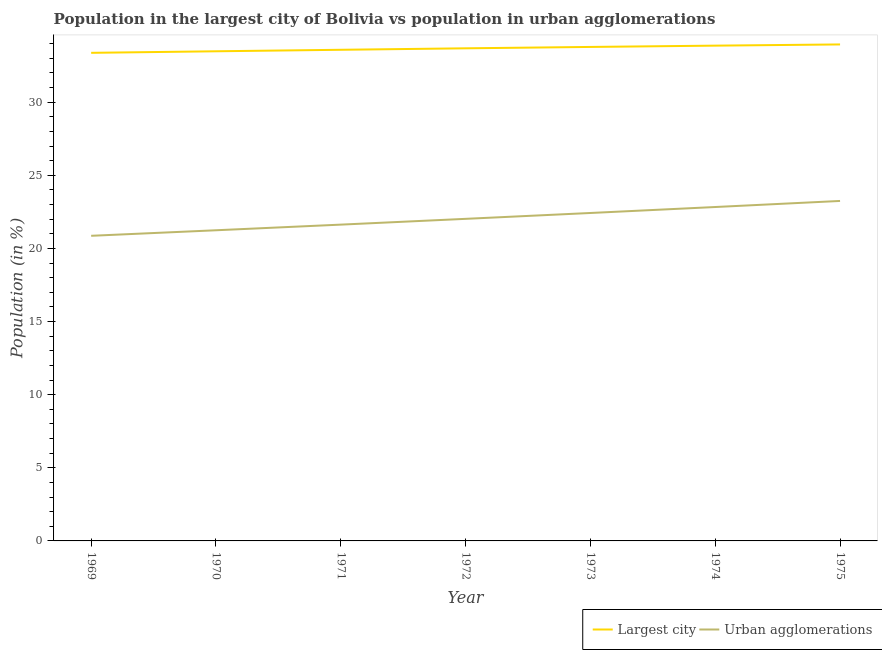Does the line corresponding to population in the largest city intersect with the line corresponding to population in urban agglomerations?
Keep it short and to the point. No. What is the population in the largest city in 1970?
Make the answer very short. 33.48. Across all years, what is the maximum population in urban agglomerations?
Give a very brief answer. 23.25. Across all years, what is the minimum population in urban agglomerations?
Your response must be concise. 20.86. In which year was the population in the largest city maximum?
Your response must be concise. 1975. In which year was the population in urban agglomerations minimum?
Offer a very short reply. 1969. What is the total population in the largest city in the graph?
Offer a terse response. 235.7. What is the difference between the population in urban agglomerations in 1969 and that in 1970?
Ensure brevity in your answer.  -0.38. What is the difference between the population in urban agglomerations in 1969 and the population in the largest city in 1973?
Provide a short and direct response. -12.91. What is the average population in the largest city per year?
Keep it short and to the point. 33.67. In the year 1971, what is the difference between the population in the largest city and population in urban agglomerations?
Your response must be concise. 11.95. In how many years, is the population in the largest city greater than 31 %?
Offer a terse response. 7. What is the ratio of the population in urban agglomerations in 1970 to that in 1975?
Provide a short and direct response. 0.91. What is the difference between the highest and the second highest population in urban agglomerations?
Ensure brevity in your answer.  0.42. What is the difference between the highest and the lowest population in urban agglomerations?
Offer a terse response. 2.38. Is the sum of the population in the largest city in 1969 and 1974 greater than the maximum population in urban agglomerations across all years?
Offer a very short reply. Yes. Is the population in the largest city strictly less than the population in urban agglomerations over the years?
Your answer should be very brief. No. How many years are there in the graph?
Your response must be concise. 7. Are the values on the major ticks of Y-axis written in scientific E-notation?
Offer a terse response. No. How many legend labels are there?
Make the answer very short. 2. What is the title of the graph?
Your answer should be very brief. Population in the largest city of Bolivia vs population in urban agglomerations. Does "Primary completion rate" appear as one of the legend labels in the graph?
Your answer should be compact. No. What is the label or title of the Y-axis?
Offer a terse response. Population (in %). What is the Population (in %) of Largest city in 1969?
Ensure brevity in your answer.  33.37. What is the Population (in %) in Urban agglomerations in 1969?
Ensure brevity in your answer.  20.86. What is the Population (in %) in Largest city in 1970?
Offer a terse response. 33.48. What is the Population (in %) of Urban agglomerations in 1970?
Ensure brevity in your answer.  21.24. What is the Population (in %) of Largest city in 1971?
Give a very brief answer. 33.58. What is the Population (in %) of Urban agglomerations in 1971?
Offer a terse response. 21.63. What is the Population (in %) of Largest city in 1972?
Offer a very short reply. 33.68. What is the Population (in %) in Urban agglomerations in 1972?
Give a very brief answer. 22.02. What is the Population (in %) in Largest city in 1973?
Provide a succinct answer. 33.78. What is the Population (in %) of Urban agglomerations in 1973?
Make the answer very short. 22.42. What is the Population (in %) in Largest city in 1974?
Make the answer very short. 33.87. What is the Population (in %) in Urban agglomerations in 1974?
Your response must be concise. 22.83. What is the Population (in %) in Largest city in 1975?
Offer a terse response. 33.95. What is the Population (in %) in Urban agglomerations in 1975?
Offer a very short reply. 23.25. Across all years, what is the maximum Population (in %) of Largest city?
Your response must be concise. 33.95. Across all years, what is the maximum Population (in %) in Urban agglomerations?
Ensure brevity in your answer.  23.25. Across all years, what is the minimum Population (in %) in Largest city?
Provide a succinct answer. 33.37. Across all years, what is the minimum Population (in %) of Urban agglomerations?
Provide a short and direct response. 20.86. What is the total Population (in %) of Largest city in the graph?
Your answer should be compact. 235.7. What is the total Population (in %) of Urban agglomerations in the graph?
Provide a succinct answer. 154.25. What is the difference between the Population (in %) of Largest city in 1969 and that in 1970?
Your answer should be compact. -0.11. What is the difference between the Population (in %) in Urban agglomerations in 1969 and that in 1970?
Offer a terse response. -0.38. What is the difference between the Population (in %) of Largest city in 1969 and that in 1971?
Your answer should be compact. -0.21. What is the difference between the Population (in %) of Urban agglomerations in 1969 and that in 1971?
Your response must be concise. -0.76. What is the difference between the Population (in %) of Largest city in 1969 and that in 1972?
Offer a terse response. -0.31. What is the difference between the Population (in %) in Urban agglomerations in 1969 and that in 1972?
Offer a terse response. -1.16. What is the difference between the Population (in %) in Largest city in 1969 and that in 1973?
Keep it short and to the point. -0.4. What is the difference between the Population (in %) of Urban agglomerations in 1969 and that in 1973?
Your answer should be compact. -1.56. What is the difference between the Population (in %) of Largest city in 1969 and that in 1974?
Offer a terse response. -0.49. What is the difference between the Population (in %) of Urban agglomerations in 1969 and that in 1974?
Your response must be concise. -1.97. What is the difference between the Population (in %) of Largest city in 1969 and that in 1975?
Ensure brevity in your answer.  -0.57. What is the difference between the Population (in %) in Urban agglomerations in 1969 and that in 1975?
Offer a very short reply. -2.38. What is the difference between the Population (in %) of Largest city in 1970 and that in 1971?
Offer a terse response. -0.1. What is the difference between the Population (in %) in Urban agglomerations in 1970 and that in 1971?
Your response must be concise. -0.39. What is the difference between the Population (in %) of Largest city in 1970 and that in 1972?
Make the answer very short. -0.2. What is the difference between the Population (in %) of Urban agglomerations in 1970 and that in 1972?
Give a very brief answer. -0.78. What is the difference between the Population (in %) in Largest city in 1970 and that in 1973?
Your answer should be very brief. -0.3. What is the difference between the Population (in %) in Urban agglomerations in 1970 and that in 1973?
Your answer should be very brief. -1.18. What is the difference between the Population (in %) of Largest city in 1970 and that in 1974?
Provide a succinct answer. -0.39. What is the difference between the Population (in %) in Urban agglomerations in 1970 and that in 1974?
Keep it short and to the point. -1.59. What is the difference between the Population (in %) in Largest city in 1970 and that in 1975?
Give a very brief answer. -0.47. What is the difference between the Population (in %) in Urban agglomerations in 1970 and that in 1975?
Keep it short and to the point. -2. What is the difference between the Population (in %) of Largest city in 1971 and that in 1972?
Offer a very short reply. -0.1. What is the difference between the Population (in %) in Urban agglomerations in 1971 and that in 1972?
Ensure brevity in your answer.  -0.4. What is the difference between the Population (in %) in Largest city in 1971 and that in 1973?
Offer a terse response. -0.19. What is the difference between the Population (in %) of Urban agglomerations in 1971 and that in 1973?
Provide a short and direct response. -0.8. What is the difference between the Population (in %) of Largest city in 1971 and that in 1974?
Ensure brevity in your answer.  -0.28. What is the difference between the Population (in %) in Urban agglomerations in 1971 and that in 1974?
Your answer should be compact. -1.2. What is the difference between the Population (in %) in Largest city in 1971 and that in 1975?
Your response must be concise. -0.37. What is the difference between the Population (in %) in Urban agglomerations in 1971 and that in 1975?
Ensure brevity in your answer.  -1.62. What is the difference between the Population (in %) of Largest city in 1972 and that in 1973?
Ensure brevity in your answer.  -0.09. What is the difference between the Population (in %) of Urban agglomerations in 1972 and that in 1973?
Ensure brevity in your answer.  -0.4. What is the difference between the Population (in %) in Largest city in 1972 and that in 1974?
Provide a succinct answer. -0.18. What is the difference between the Population (in %) of Urban agglomerations in 1972 and that in 1974?
Offer a very short reply. -0.81. What is the difference between the Population (in %) of Largest city in 1972 and that in 1975?
Ensure brevity in your answer.  -0.26. What is the difference between the Population (in %) of Urban agglomerations in 1972 and that in 1975?
Ensure brevity in your answer.  -1.22. What is the difference between the Population (in %) of Largest city in 1973 and that in 1974?
Ensure brevity in your answer.  -0.09. What is the difference between the Population (in %) of Urban agglomerations in 1973 and that in 1974?
Your response must be concise. -0.41. What is the difference between the Population (in %) of Largest city in 1973 and that in 1975?
Your answer should be very brief. -0.17. What is the difference between the Population (in %) of Urban agglomerations in 1973 and that in 1975?
Offer a terse response. -0.82. What is the difference between the Population (in %) in Largest city in 1974 and that in 1975?
Offer a terse response. -0.08. What is the difference between the Population (in %) of Urban agglomerations in 1974 and that in 1975?
Offer a very short reply. -0.42. What is the difference between the Population (in %) in Largest city in 1969 and the Population (in %) in Urban agglomerations in 1970?
Your answer should be very brief. 12.13. What is the difference between the Population (in %) in Largest city in 1969 and the Population (in %) in Urban agglomerations in 1971?
Your response must be concise. 11.75. What is the difference between the Population (in %) of Largest city in 1969 and the Population (in %) of Urban agglomerations in 1972?
Keep it short and to the point. 11.35. What is the difference between the Population (in %) of Largest city in 1969 and the Population (in %) of Urban agglomerations in 1973?
Provide a short and direct response. 10.95. What is the difference between the Population (in %) in Largest city in 1969 and the Population (in %) in Urban agglomerations in 1974?
Offer a terse response. 10.54. What is the difference between the Population (in %) of Largest city in 1969 and the Population (in %) of Urban agglomerations in 1975?
Provide a succinct answer. 10.13. What is the difference between the Population (in %) of Largest city in 1970 and the Population (in %) of Urban agglomerations in 1971?
Offer a very short reply. 11.85. What is the difference between the Population (in %) in Largest city in 1970 and the Population (in %) in Urban agglomerations in 1972?
Make the answer very short. 11.46. What is the difference between the Population (in %) in Largest city in 1970 and the Population (in %) in Urban agglomerations in 1973?
Provide a succinct answer. 11.06. What is the difference between the Population (in %) of Largest city in 1970 and the Population (in %) of Urban agglomerations in 1974?
Ensure brevity in your answer.  10.65. What is the difference between the Population (in %) of Largest city in 1970 and the Population (in %) of Urban agglomerations in 1975?
Ensure brevity in your answer.  10.23. What is the difference between the Population (in %) in Largest city in 1971 and the Population (in %) in Urban agglomerations in 1972?
Provide a short and direct response. 11.56. What is the difference between the Population (in %) in Largest city in 1971 and the Population (in %) in Urban agglomerations in 1973?
Give a very brief answer. 11.16. What is the difference between the Population (in %) of Largest city in 1971 and the Population (in %) of Urban agglomerations in 1974?
Provide a succinct answer. 10.75. What is the difference between the Population (in %) in Largest city in 1971 and the Population (in %) in Urban agglomerations in 1975?
Ensure brevity in your answer.  10.34. What is the difference between the Population (in %) of Largest city in 1972 and the Population (in %) of Urban agglomerations in 1973?
Offer a terse response. 11.26. What is the difference between the Population (in %) in Largest city in 1972 and the Population (in %) in Urban agglomerations in 1974?
Offer a terse response. 10.85. What is the difference between the Population (in %) of Largest city in 1972 and the Population (in %) of Urban agglomerations in 1975?
Provide a succinct answer. 10.44. What is the difference between the Population (in %) in Largest city in 1973 and the Population (in %) in Urban agglomerations in 1974?
Your answer should be very brief. 10.95. What is the difference between the Population (in %) of Largest city in 1973 and the Population (in %) of Urban agglomerations in 1975?
Provide a succinct answer. 10.53. What is the difference between the Population (in %) of Largest city in 1974 and the Population (in %) of Urban agglomerations in 1975?
Ensure brevity in your answer.  10.62. What is the average Population (in %) in Largest city per year?
Your answer should be compact. 33.67. What is the average Population (in %) of Urban agglomerations per year?
Offer a terse response. 22.04. In the year 1969, what is the difference between the Population (in %) of Largest city and Population (in %) of Urban agglomerations?
Your answer should be compact. 12.51. In the year 1970, what is the difference between the Population (in %) in Largest city and Population (in %) in Urban agglomerations?
Provide a short and direct response. 12.24. In the year 1971, what is the difference between the Population (in %) in Largest city and Population (in %) in Urban agglomerations?
Make the answer very short. 11.95. In the year 1972, what is the difference between the Population (in %) in Largest city and Population (in %) in Urban agglomerations?
Your answer should be compact. 11.66. In the year 1973, what is the difference between the Population (in %) of Largest city and Population (in %) of Urban agglomerations?
Provide a short and direct response. 11.35. In the year 1974, what is the difference between the Population (in %) of Largest city and Population (in %) of Urban agglomerations?
Give a very brief answer. 11.03. In the year 1975, what is the difference between the Population (in %) of Largest city and Population (in %) of Urban agglomerations?
Provide a short and direct response. 10.7. What is the ratio of the Population (in %) in Urban agglomerations in 1969 to that in 1970?
Offer a very short reply. 0.98. What is the ratio of the Population (in %) of Urban agglomerations in 1969 to that in 1971?
Your answer should be very brief. 0.96. What is the ratio of the Population (in %) of Largest city in 1969 to that in 1972?
Provide a short and direct response. 0.99. What is the ratio of the Population (in %) in Urban agglomerations in 1969 to that in 1972?
Keep it short and to the point. 0.95. What is the ratio of the Population (in %) in Urban agglomerations in 1969 to that in 1973?
Your response must be concise. 0.93. What is the ratio of the Population (in %) in Largest city in 1969 to that in 1974?
Your response must be concise. 0.99. What is the ratio of the Population (in %) of Urban agglomerations in 1969 to that in 1974?
Keep it short and to the point. 0.91. What is the ratio of the Population (in %) of Largest city in 1969 to that in 1975?
Offer a very short reply. 0.98. What is the ratio of the Population (in %) in Urban agglomerations in 1969 to that in 1975?
Make the answer very short. 0.9. What is the ratio of the Population (in %) of Largest city in 1970 to that in 1971?
Keep it short and to the point. 1. What is the ratio of the Population (in %) in Urban agglomerations in 1970 to that in 1971?
Ensure brevity in your answer.  0.98. What is the ratio of the Population (in %) in Largest city in 1970 to that in 1972?
Provide a succinct answer. 0.99. What is the ratio of the Population (in %) in Urban agglomerations in 1970 to that in 1972?
Give a very brief answer. 0.96. What is the ratio of the Population (in %) in Urban agglomerations in 1970 to that in 1973?
Your answer should be very brief. 0.95. What is the ratio of the Population (in %) of Urban agglomerations in 1970 to that in 1974?
Your response must be concise. 0.93. What is the ratio of the Population (in %) of Largest city in 1970 to that in 1975?
Provide a succinct answer. 0.99. What is the ratio of the Population (in %) of Urban agglomerations in 1970 to that in 1975?
Provide a short and direct response. 0.91. What is the ratio of the Population (in %) in Urban agglomerations in 1971 to that in 1972?
Your answer should be very brief. 0.98. What is the ratio of the Population (in %) of Largest city in 1971 to that in 1973?
Make the answer very short. 0.99. What is the ratio of the Population (in %) of Urban agglomerations in 1971 to that in 1973?
Provide a short and direct response. 0.96. What is the ratio of the Population (in %) of Urban agglomerations in 1971 to that in 1974?
Provide a short and direct response. 0.95. What is the ratio of the Population (in %) in Urban agglomerations in 1971 to that in 1975?
Provide a succinct answer. 0.93. What is the ratio of the Population (in %) of Urban agglomerations in 1972 to that in 1973?
Make the answer very short. 0.98. What is the ratio of the Population (in %) of Largest city in 1972 to that in 1974?
Keep it short and to the point. 0.99. What is the ratio of the Population (in %) of Urban agglomerations in 1972 to that in 1974?
Offer a very short reply. 0.96. What is the ratio of the Population (in %) in Largest city in 1972 to that in 1975?
Your answer should be compact. 0.99. What is the ratio of the Population (in %) in Urban agglomerations in 1972 to that in 1975?
Your answer should be compact. 0.95. What is the ratio of the Population (in %) of Largest city in 1973 to that in 1974?
Your answer should be compact. 1. What is the ratio of the Population (in %) in Urban agglomerations in 1973 to that in 1974?
Your answer should be very brief. 0.98. What is the ratio of the Population (in %) of Urban agglomerations in 1973 to that in 1975?
Your response must be concise. 0.96. What is the ratio of the Population (in %) of Largest city in 1974 to that in 1975?
Provide a short and direct response. 1. What is the ratio of the Population (in %) of Urban agglomerations in 1974 to that in 1975?
Offer a terse response. 0.98. What is the difference between the highest and the second highest Population (in %) in Largest city?
Offer a terse response. 0.08. What is the difference between the highest and the second highest Population (in %) in Urban agglomerations?
Offer a very short reply. 0.42. What is the difference between the highest and the lowest Population (in %) in Largest city?
Your answer should be very brief. 0.57. What is the difference between the highest and the lowest Population (in %) of Urban agglomerations?
Give a very brief answer. 2.38. 